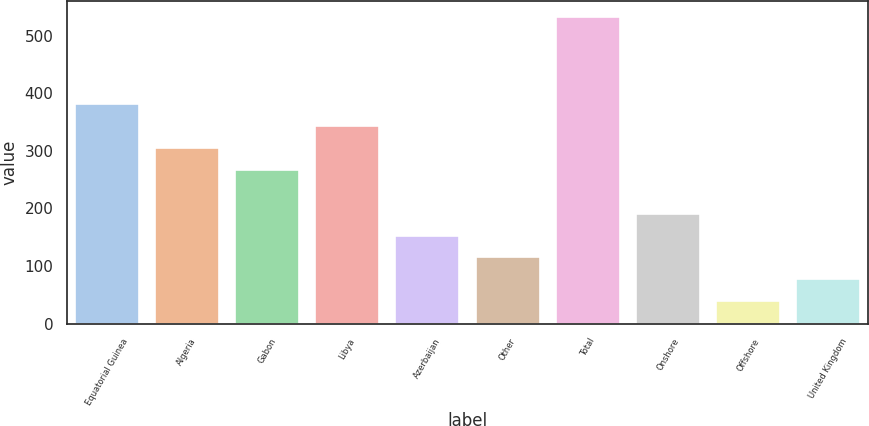Convert chart. <chart><loc_0><loc_0><loc_500><loc_500><bar_chart><fcel>Equatorial Guinea<fcel>Algeria<fcel>Gabon<fcel>Libya<fcel>Azerbaijan<fcel>Other<fcel>Total<fcel>Onshore<fcel>Offshore<fcel>United Kingdom<nl><fcel>381<fcel>305<fcel>267<fcel>343<fcel>153<fcel>115<fcel>533<fcel>191<fcel>39<fcel>77<nl></chart> 